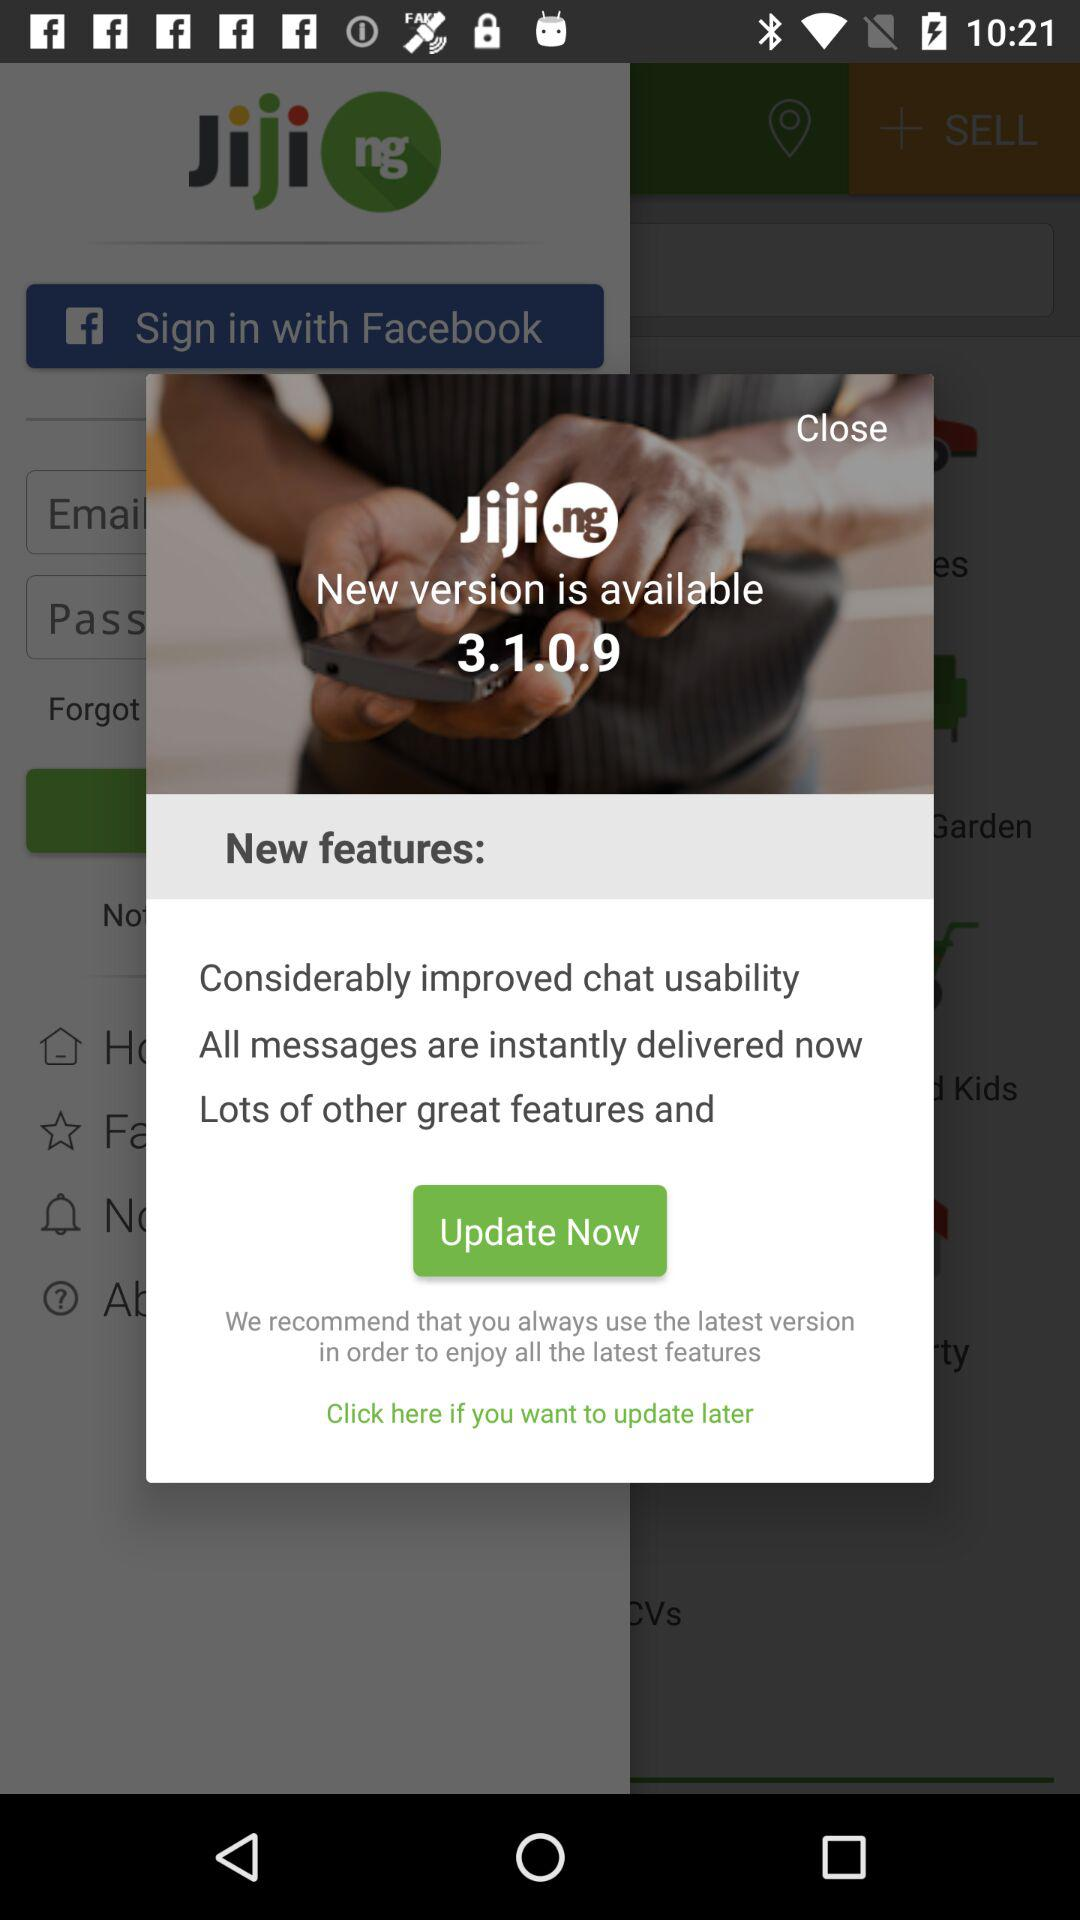What is the name of the application? The name of the application is "Jiji.ng". 